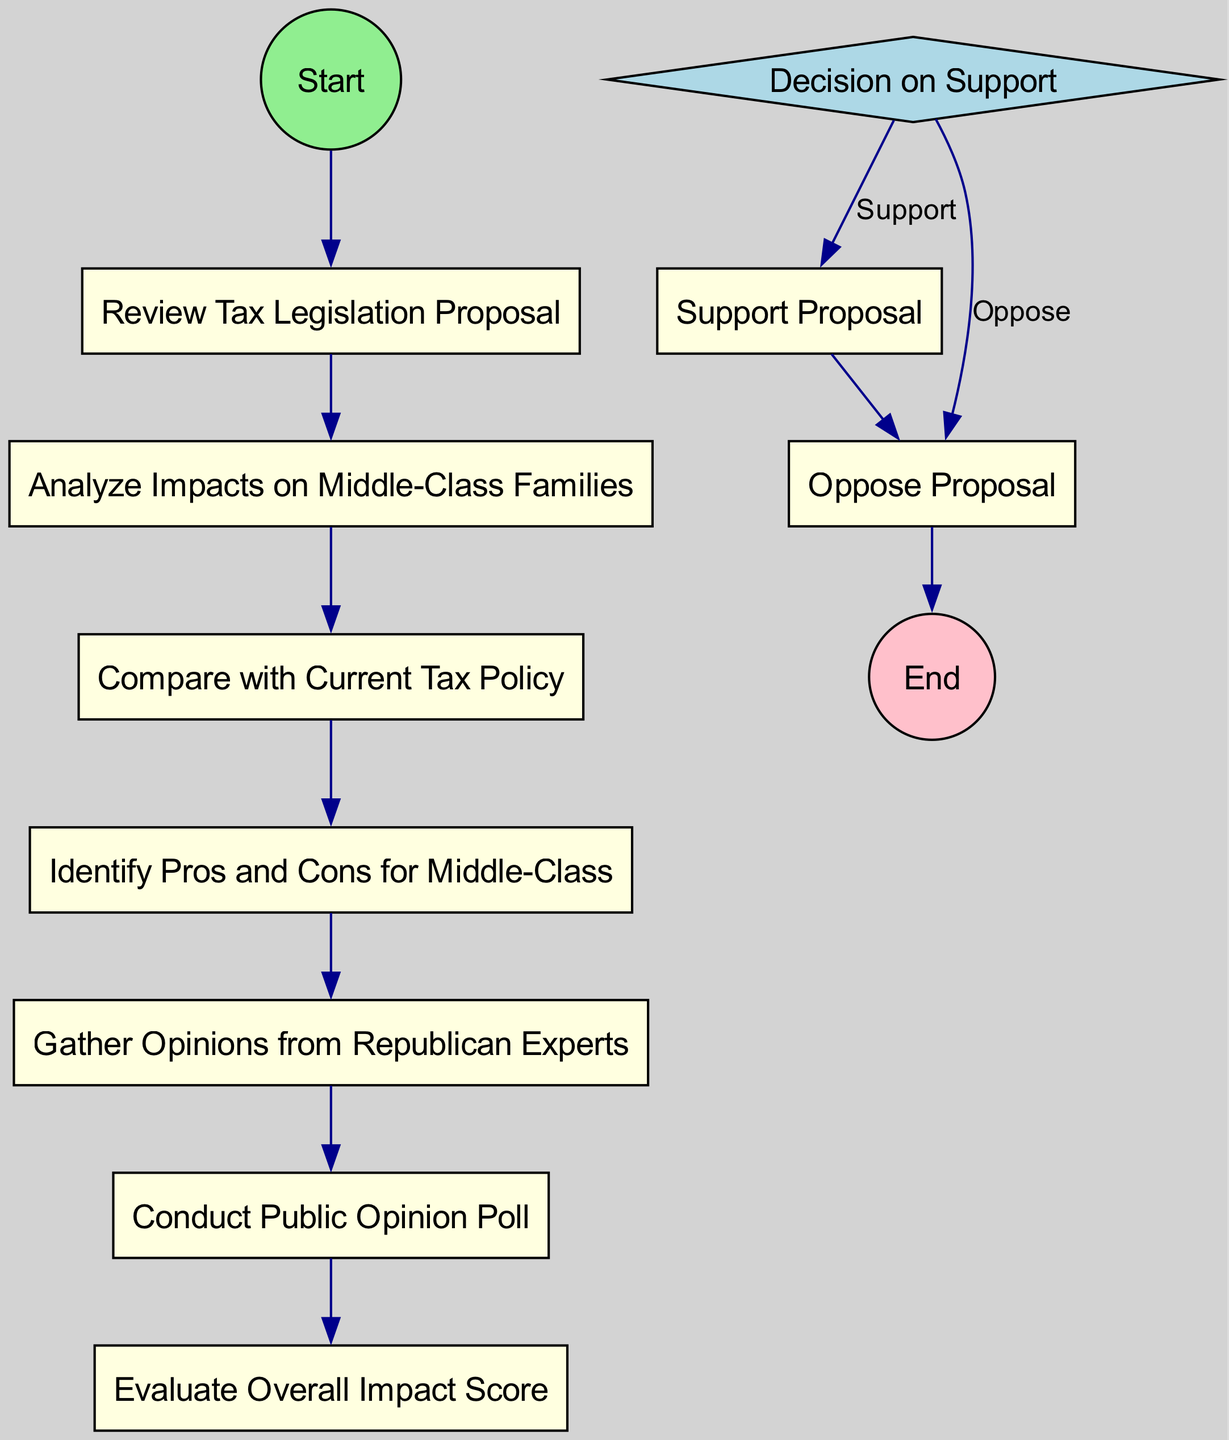What is the first action in the diagram? The first action node in the diagram is "Review Tax Legislation Proposal." This is evident as it is directly connected to the start event node labeled "Start."
Answer: Review Tax Legislation Proposal How many total actions are represented in the diagram? There are a total of 6 action nodes represented in the diagram. These are: "Review Tax Legislation Proposal," "Analyze Impacts on Middle-Class Families," "Compare with Current Tax Policy," "Identify Pros and Cons for Middle-Class," "Gather Opinions from Republican Experts," and "Conduct Public Opinion Poll."
Answer: 6 What decision is made in the diagram? The diagram displays a decision node labeled "Decision on Support," which has two branches: "Support" and "Oppose." This indicates that a decision must be made regarding the proposal's support.
Answer: Decision on Support What follows after "Evaluate Overall Impact Score"? After "Evaluate Overall Impact Score," the flow leads to the decision node labeled "Decision on Support." Therefore, the next step is to make a decision regarding the proposal based on the evaluation score.
Answer: Decision on Support What is the last action taken in the diagram? The last action taken in the diagram is contingent on the decision made; if the proposal is supported or opposed, it leads to either "Support Proposal" or "Oppose Proposal." However, these actions ultimately lead to the "End" node.
Answer: Support Proposal or Oppose Proposal How is public opinion incorporated into the evaluation process? Public opinion is incorporated through the action node labeled "Conduct Public Opinion Poll," which is connected to the evaluation of the impact on middle-class families, indicating its role in influencing the overall assessment of the proposal.
Answer: Conduct Public Opinion Poll What type of node is "Decision on Support"? "Decision on Support" is a decision node, which is distinguished by its diamond shape in the diagram, indicating a branching point where a choice must be made based on the previous evaluations.
Answer: Decision node What are the pros and cons identified for in the diagram? The pros and cons in the diagram are specifically identified for "Middle-Class Families," as specified in the action node labeled "Identify Pros and Cons for Middle-Class."
Answer: Middle-Class Families 